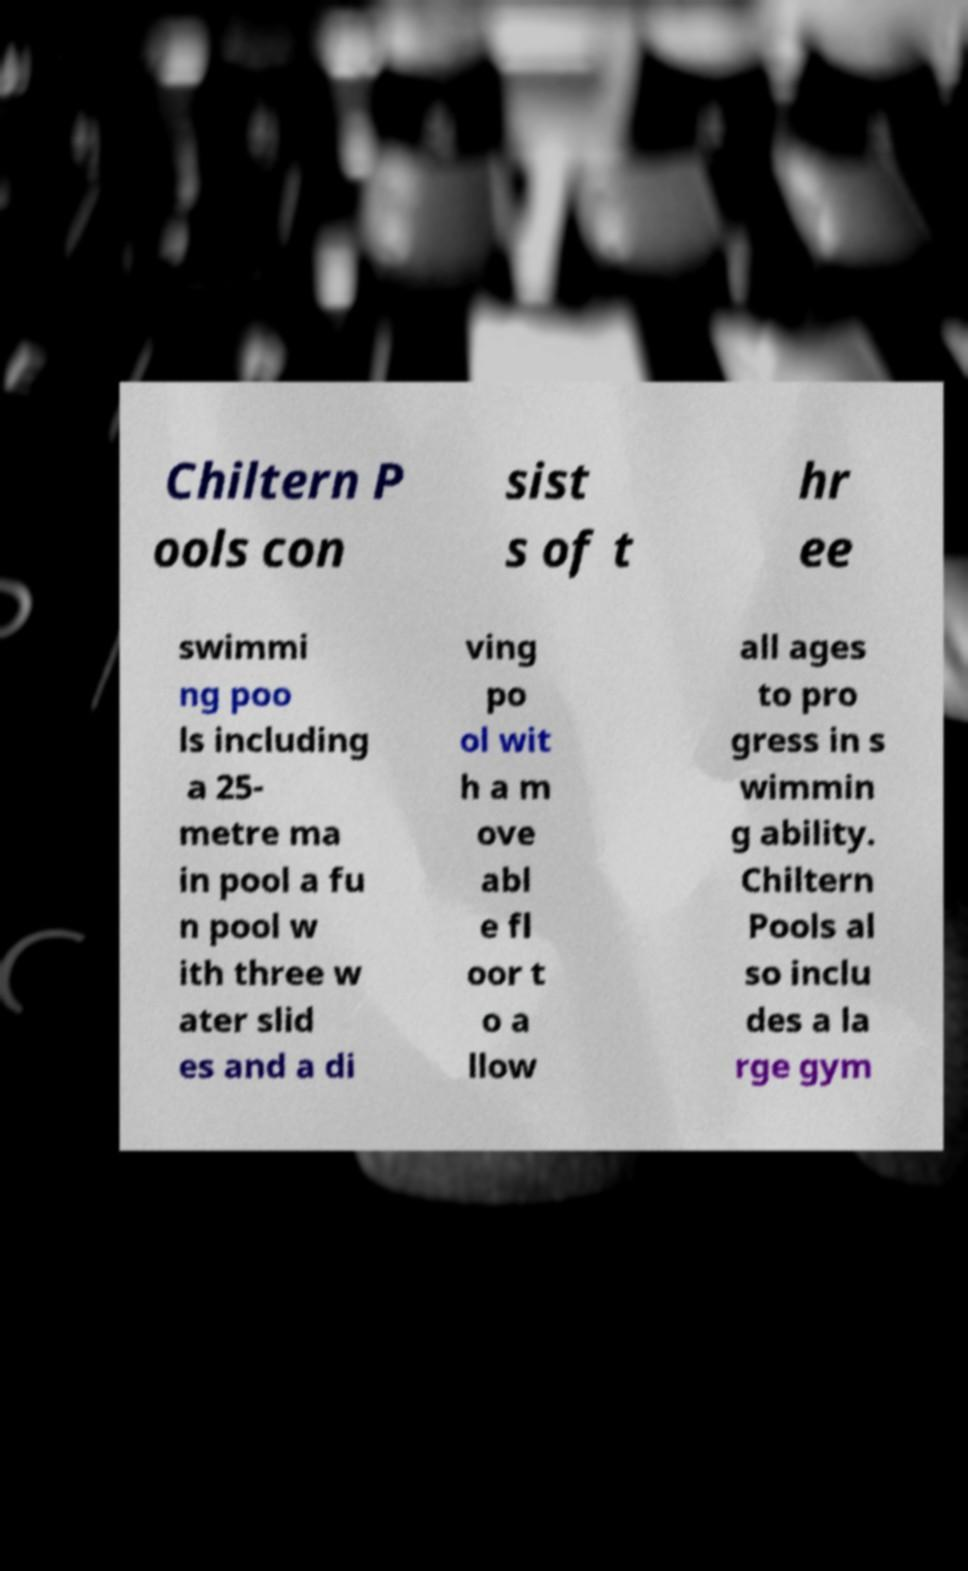Could you extract and type out the text from this image? Chiltern P ools con sist s of t hr ee swimmi ng poo ls including a 25- metre ma in pool a fu n pool w ith three w ater slid es and a di ving po ol wit h a m ove abl e fl oor t o a llow all ages to pro gress in s wimmin g ability. Chiltern Pools al so inclu des a la rge gym 